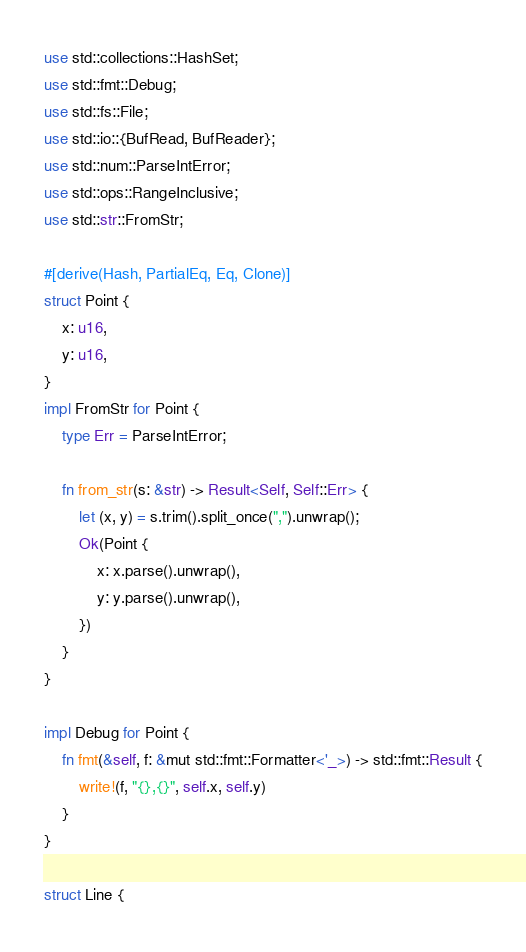<code> <loc_0><loc_0><loc_500><loc_500><_Rust_>use std::collections::HashSet;
use std::fmt::Debug;
use std::fs::File;
use std::io::{BufRead, BufReader};
use std::num::ParseIntError;
use std::ops::RangeInclusive;
use std::str::FromStr;

#[derive(Hash, PartialEq, Eq, Clone)]
struct Point {
    x: u16,
    y: u16,
}
impl FromStr for Point {
    type Err = ParseIntError;

    fn from_str(s: &str) -> Result<Self, Self::Err> {
        let (x, y) = s.trim().split_once(",").unwrap();
        Ok(Point {
            x: x.parse().unwrap(),
            y: y.parse().unwrap(),
        })
    }
}

impl Debug for Point {
    fn fmt(&self, f: &mut std::fmt::Formatter<'_>) -> std::fmt::Result {
        write!(f, "{},{}", self.x, self.y)
    }
}

struct Line {</code> 